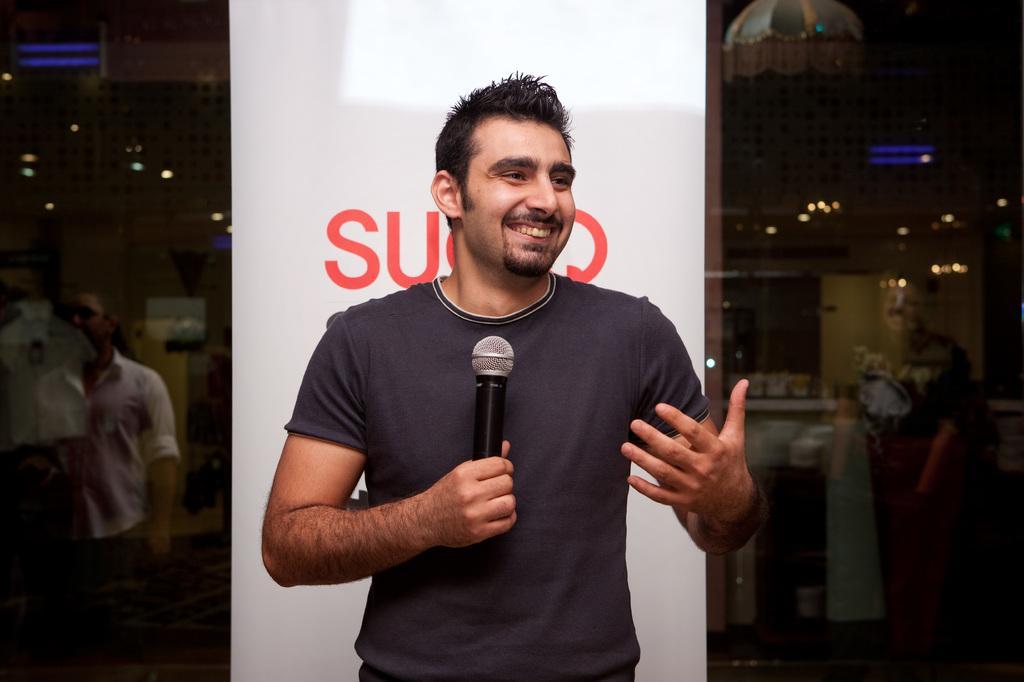How would you summarize this image in a sentence or two? There is a man standing behind the banner holding a microphone. 